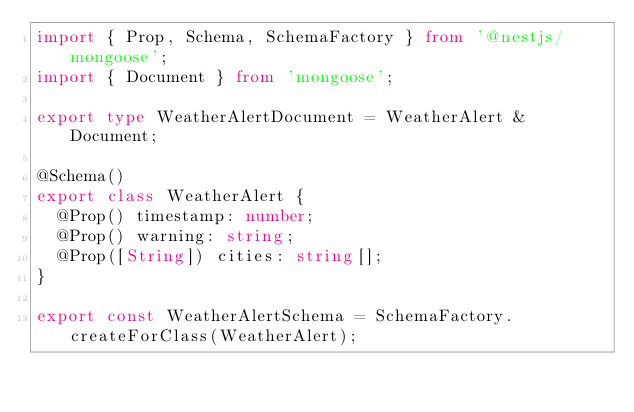<code> <loc_0><loc_0><loc_500><loc_500><_TypeScript_>import { Prop, Schema, SchemaFactory } from '@nestjs/mongoose';
import { Document } from 'mongoose';

export type WeatherAlertDocument = WeatherAlert & Document;

@Schema()
export class WeatherAlert {
  @Prop() timestamp: number;
  @Prop() warning: string;
  @Prop([String]) cities: string[];
}

export const WeatherAlertSchema = SchemaFactory.createForClass(WeatherAlert);

</code> 